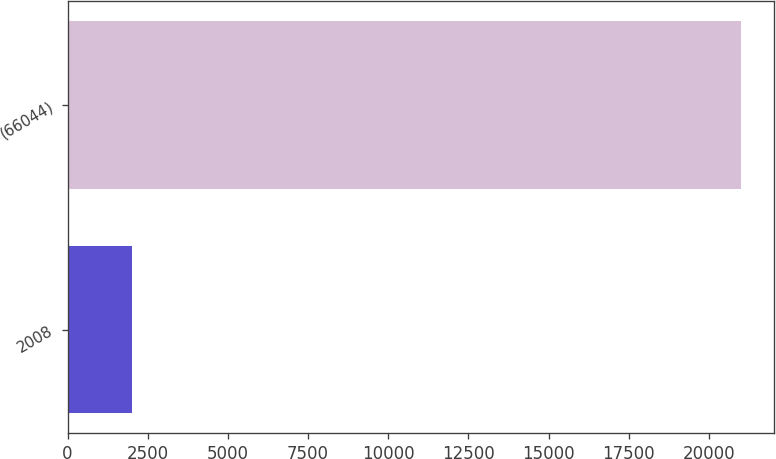<chart> <loc_0><loc_0><loc_500><loc_500><bar_chart><fcel>2008<fcel>(66044)<nl><fcel>2007<fcel>20997<nl></chart> 